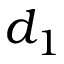Convert formula to latex. <formula><loc_0><loc_0><loc_500><loc_500>d _ { 1 }</formula> 